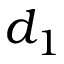Convert formula to latex. <formula><loc_0><loc_0><loc_500><loc_500>d _ { 1 }</formula> 